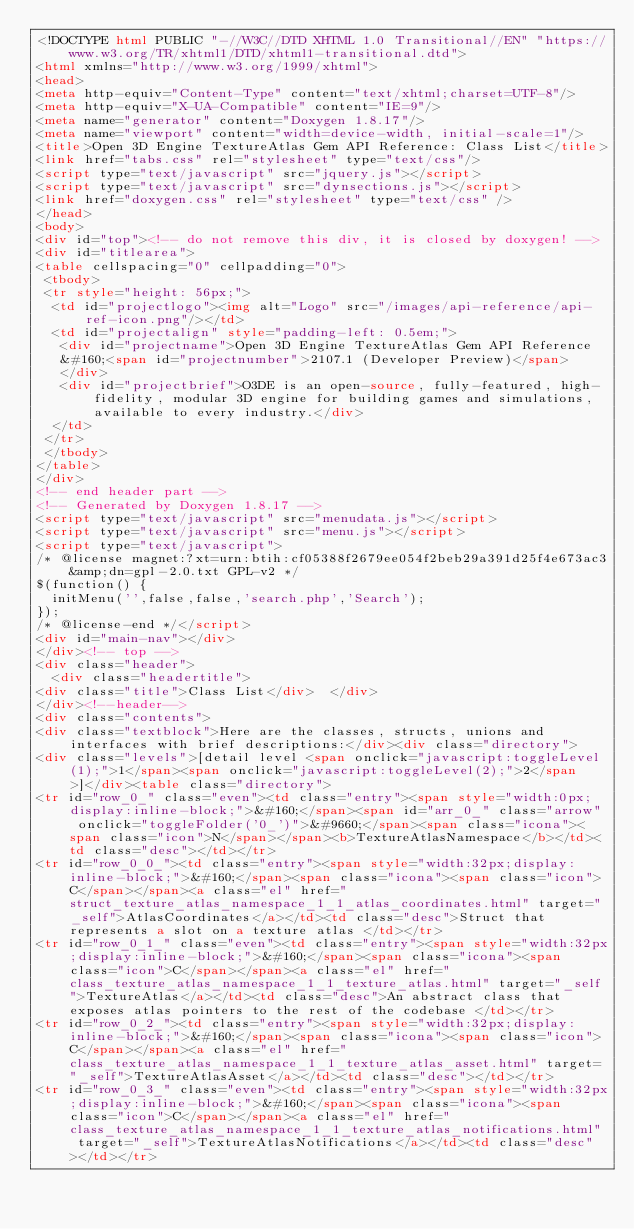Convert code to text. <code><loc_0><loc_0><loc_500><loc_500><_HTML_><!DOCTYPE html PUBLIC "-//W3C//DTD XHTML 1.0 Transitional//EN" "https://www.w3.org/TR/xhtml1/DTD/xhtml1-transitional.dtd">
<html xmlns="http://www.w3.org/1999/xhtml">
<head>
<meta http-equiv="Content-Type" content="text/xhtml;charset=UTF-8"/>
<meta http-equiv="X-UA-Compatible" content="IE=9"/>
<meta name="generator" content="Doxygen 1.8.17"/>
<meta name="viewport" content="width=device-width, initial-scale=1"/>
<title>Open 3D Engine TextureAtlas Gem API Reference: Class List</title>
<link href="tabs.css" rel="stylesheet" type="text/css"/>
<script type="text/javascript" src="jquery.js"></script>
<script type="text/javascript" src="dynsections.js"></script>
<link href="doxygen.css" rel="stylesheet" type="text/css" />
</head>
<body>
<div id="top"><!-- do not remove this div, it is closed by doxygen! -->
<div id="titlearea">
<table cellspacing="0" cellpadding="0">
 <tbody>
 <tr style="height: 56px;">
  <td id="projectlogo"><img alt="Logo" src="/images/api-reference/api-ref-icon.png"/></td>
  <td id="projectalign" style="padding-left: 0.5em;">
   <div id="projectname">Open 3D Engine TextureAtlas Gem API Reference
   &#160;<span id="projectnumber">2107.1 (Developer Preview)</span>
   </div>
   <div id="projectbrief">O3DE is an open-source, fully-featured, high-fidelity, modular 3D engine for building games and simulations, available to every industry.</div>
  </td>
 </tr>
 </tbody>
</table>
</div>
<!-- end header part -->
<!-- Generated by Doxygen 1.8.17 -->
<script type="text/javascript" src="menudata.js"></script>
<script type="text/javascript" src="menu.js"></script>
<script type="text/javascript">
/* @license magnet:?xt=urn:btih:cf05388f2679ee054f2beb29a391d25f4e673ac3&amp;dn=gpl-2.0.txt GPL-v2 */
$(function() {
  initMenu('',false,false,'search.php','Search');
});
/* @license-end */</script>
<div id="main-nav"></div>
</div><!-- top -->
<div class="header">
  <div class="headertitle">
<div class="title">Class List</div>  </div>
</div><!--header-->
<div class="contents">
<div class="textblock">Here are the classes, structs, unions and interfaces with brief descriptions:</div><div class="directory">
<div class="levels">[detail level <span onclick="javascript:toggleLevel(1);">1</span><span onclick="javascript:toggleLevel(2);">2</span>]</div><table class="directory">
<tr id="row_0_" class="even"><td class="entry"><span style="width:0px;display:inline-block;">&#160;</span><span id="arr_0_" class="arrow" onclick="toggleFolder('0_')">&#9660;</span><span class="icona"><span class="icon">N</span></span><b>TextureAtlasNamespace</b></td><td class="desc"></td></tr>
<tr id="row_0_0_"><td class="entry"><span style="width:32px;display:inline-block;">&#160;</span><span class="icona"><span class="icon">C</span></span><a class="el" href="struct_texture_atlas_namespace_1_1_atlas_coordinates.html" target="_self">AtlasCoordinates</a></td><td class="desc">Struct that represents a slot on a texture atlas </td></tr>
<tr id="row_0_1_" class="even"><td class="entry"><span style="width:32px;display:inline-block;">&#160;</span><span class="icona"><span class="icon">C</span></span><a class="el" href="class_texture_atlas_namespace_1_1_texture_atlas.html" target="_self">TextureAtlas</a></td><td class="desc">An abstract class that exposes atlas pointers to the rest of the codebase </td></tr>
<tr id="row_0_2_"><td class="entry"><span style="width:32px;display:inline-block;">&#160;</span><span class="icona"><span class="icon">C</span></span><a class="el" href="class_texture_atlas_namespace_1_1_texture_atlas_asset.html" target="_self">TextureAtlasAsset</a></td><td class="desc"></td></tr>
<tr id="row_0_3_" class="even"><td class="entry"><span style="width:32px;display:inline-block;">&#160;</span><span class="icona"><span class="icon">C</span></span><a class="el" href="class_texture_atlas_namespace_1_1_texture_atlas_notifications.html" target="_self">TextureAtlasNotifications</a></td><td class="desc"></td></tr></code> 